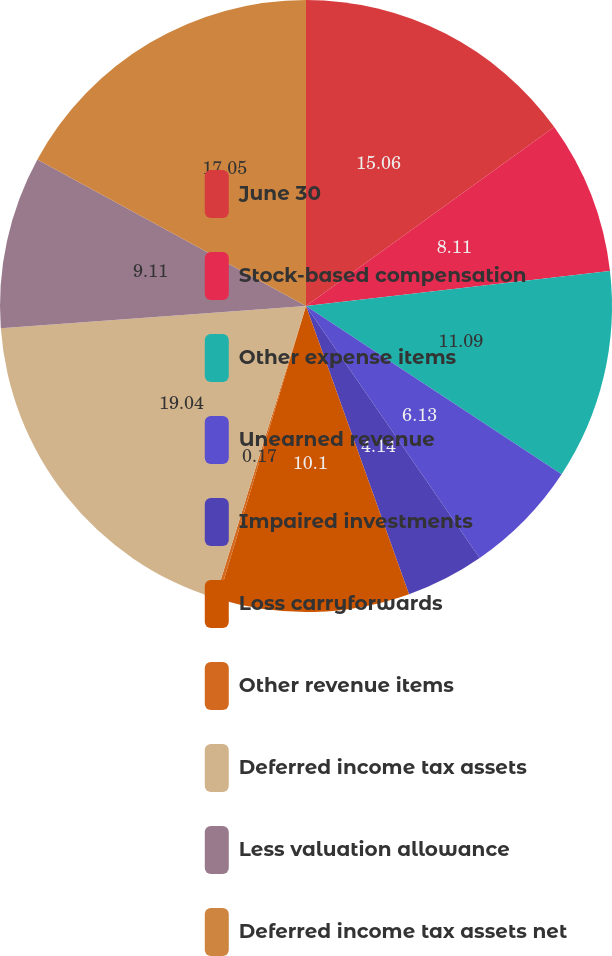Convert chart to OTSL. <chart><loc_0><loc_0><loc_500><loc_500><pie_chart><fcel>June 30<fcel>Stock-based compensation<fcel>Other expense items<fcel>Unearned revenue<fcel>Impaired investments<fcel>Loss carryforwards<fcel>Other revenue items<fcel>Deferred income tax assets<fcel>Less valuation allowance<fcel>Deferred income tax assets net<nl><fcel>15.06%<fcel>8.11%<fcel>11.09%<fcel>6.13%<fcel>4.14%<fcel>10.1%<fcel>0.17%<fcel>19.03%<fcel>9.11%<fcel>17.05%<nl></chart> 